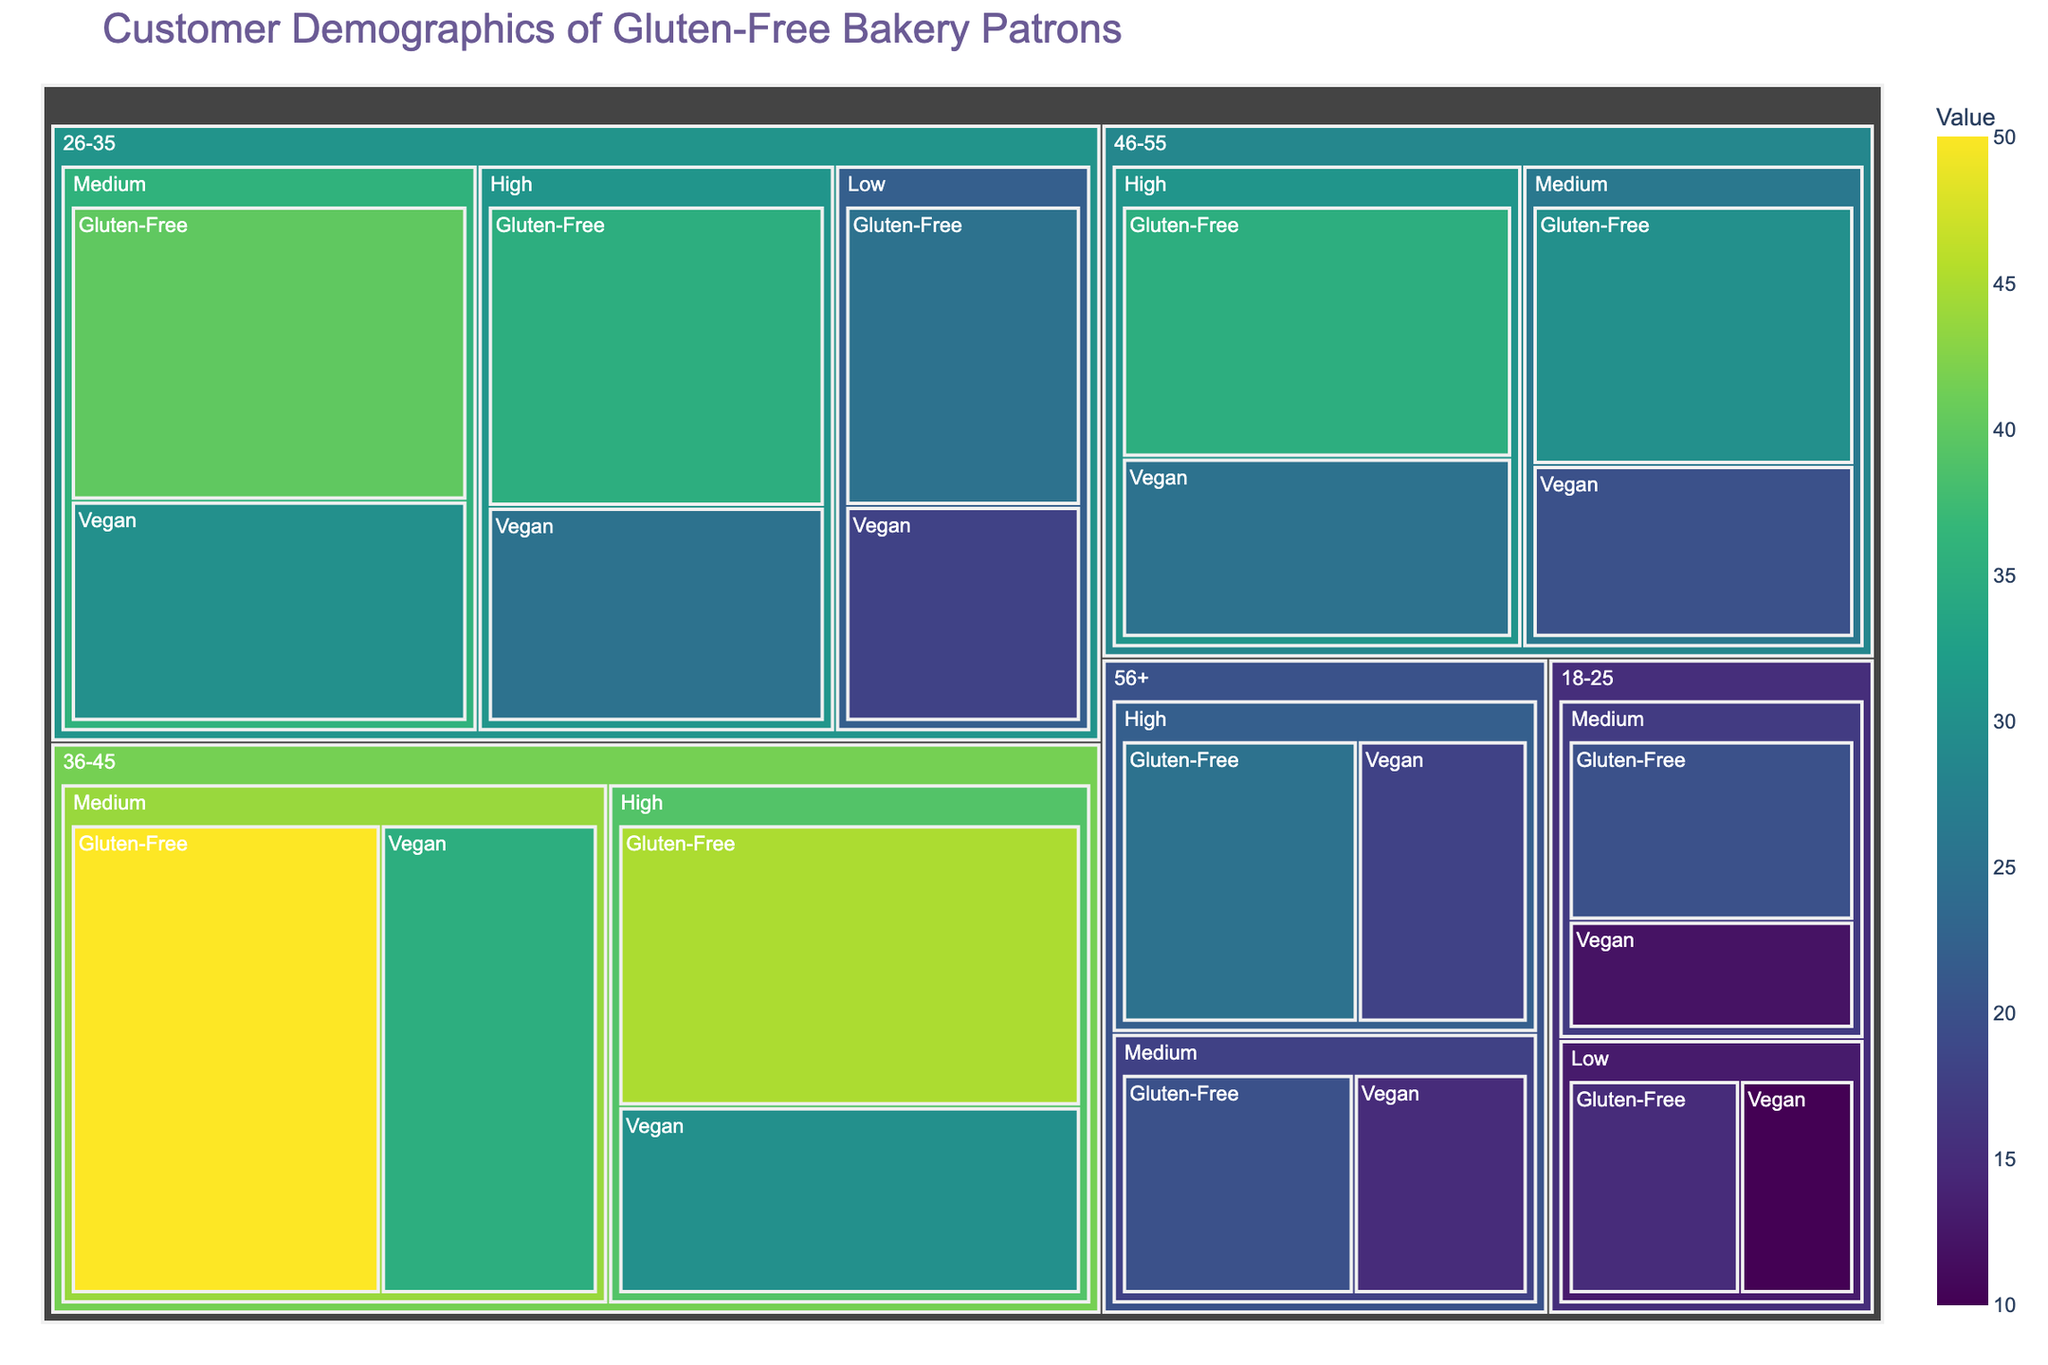What is the title of the figure? The title is usually displayed prominently, often at the top of the figure. In this case, it's "Customer Demographics of Gluten-Free Bakery Patrons."
Answer: Customer Demographics of Gluten-Free Bakery Patrons Which age group has the highest value for gluten-free dietary preferences? To determine this, look at the size and color intensity of the segments for the gluten-free preference across all age groups. The age group 36-45 with a medium income level has the largest box, indicating its value is the highest.
Answer: 36-45 In the 26-35 age group, which income level has a higher value for vegan dietary preference? Compare the segments for vegan dietary preference within the 26-35 age group. The medium income level has a higher value than both low and high.
Answer: Medium What is the total value for gluten-free preferences in the 26-35 age group? Sum the values for gluten-free preferences in the 26-35 age group across all income levels: 25 (Low) + 40 (Medium) + 35 (High) = 100.
Answer: 100 Which dietary preference has a higher value in the 46-55 age group, gluten-free or vegan? Compare the sum of values for each dietary preference in the 46-55 age group. Gluten-free: 30 (Medium) + 35 (High) = 65. Vegan: 20 (Medium) + 25 (High) = 45. Gluten-free has a higher value.
Answer: Gluten-free In which age group and income level is the smallest segment for gluten-free dietary preferences found? Look for the smallest segment related to gluten-free dietary preferences across all age groups and income levels. The 18-25 age group with low income has the smallest segment with a value of 15.
Answer: 18-25, Low Compare the values between medium-income vegan preferences in the 18-25 and 26-35 age groups. Which one is higher? Check the values for vegan preferences in the medium-income range for both age groups. The 26-35 age group has 30, which is higher than the 12 in the 18-25 age group.
Answer: 26-35 What is the value distribution for vegan dietary preferences across all age groups? List the values for vegan dietary preferences in all age groups: 18-25 (10 Low, 12 Medium), 26-35 (18 Low, 30 Medium, 25 High), 36-45 (35 Medium, 30 High), 46-55 (20 Medium, 25 High), 56+ (15 Medium, 18 High).
Answer: 10, 12, 18, 30, 25, 35, 30, 20, 25, 15, 18 Which age group has the least interest in vegan dietary preferences? Sum the values of vegan preferences for each age group and compare them. The 18-25 age group has the least interest with a total of 22 (10 Low + 12 Medium).
Answer: 18-25 